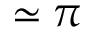Convert formula to latex. <formula><loc_0><loc_0><loc_500><loc_500>\simeq \pi</formula> 